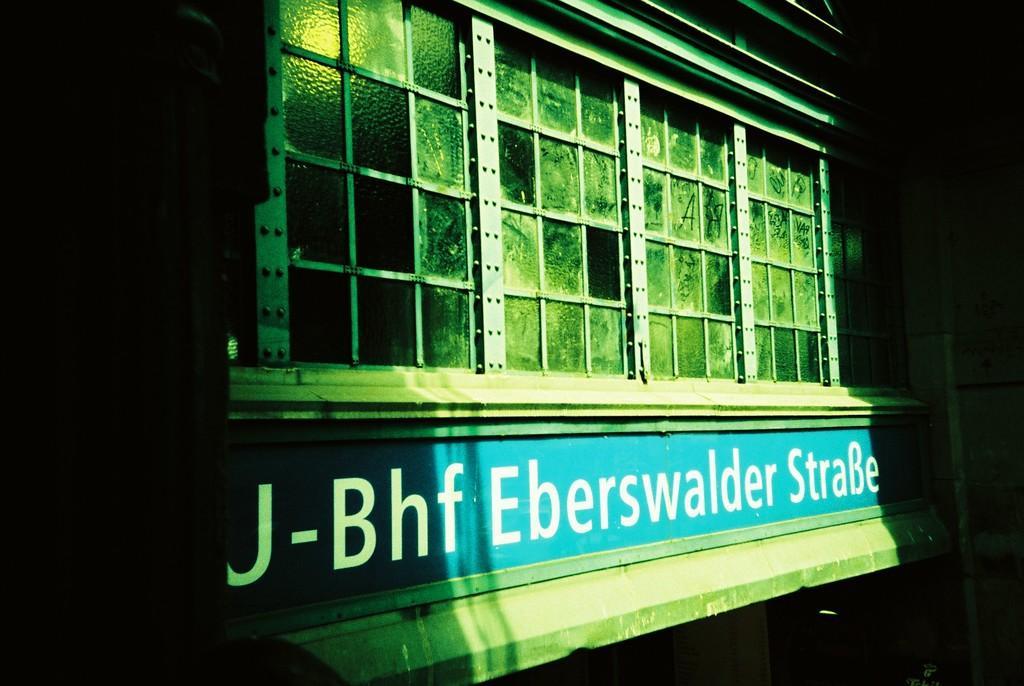Describe this image in one or two sentences. In the image there is a building with glasses and name board with name. And on the building there is a light. 